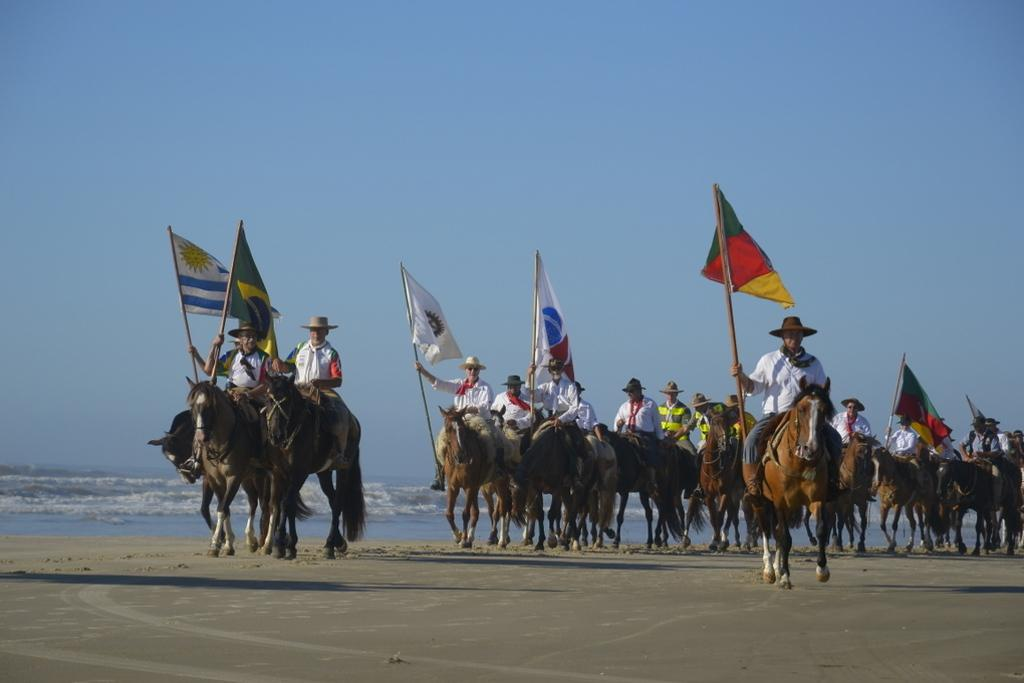What are the persons in the image doing? The persons in the image are sitting on a horse. What are the persons holding while sitting on the horse? The persons are holding flags. What type of surface is the horse standing on? The horse is on sand. What can be seen in the distance in the image? There is water visible in the background of the image, and the sky is blue. What type of pear is being used as a stop sign in the image? There is no pear or stop sign present in the image. 